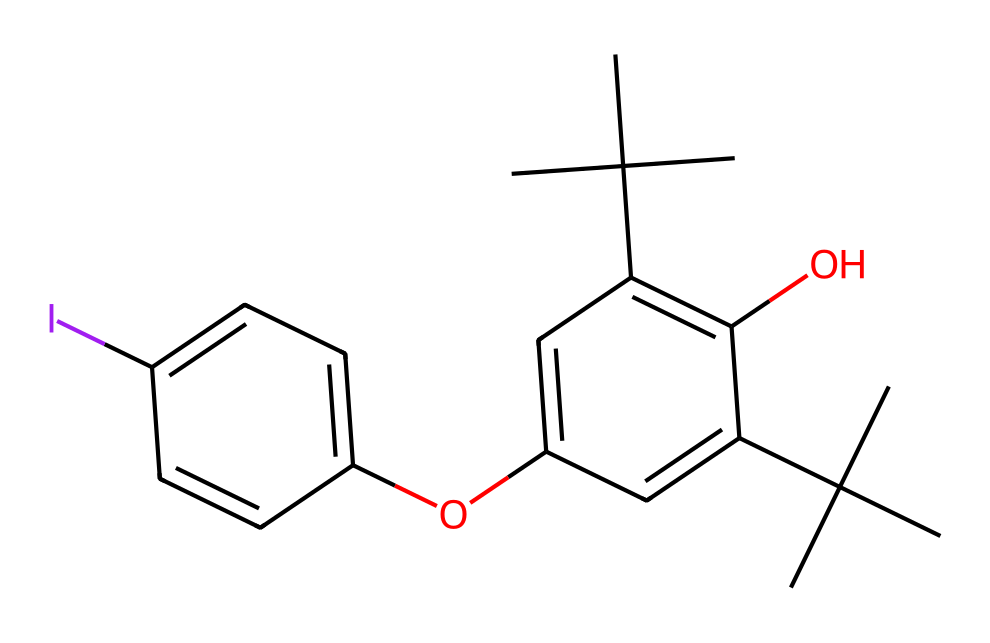what is the molecular formula of this compound? To determine the molecular formula, we count the different atoms present in the SMILES. The significant atomic symbols in the structure include carbon (C), hydrogen (H), iodine (I), and oxygen (O). By counting, we find C: 16, H: 18, O: 2, I: 1. Thus, the molecular formula is C16H18O2I.
Answer: C16H18O2I how many rings are present in the chemical structure? The structure features two benzene rings connected by ether linkages. Each benzene ring represents one cyclic structure. Therefore, when we count these, we find there are 2 rings present.
Answer: 2 what functional groups are present in this compound? Analyzing the structure, it can be observed that there are hydroxyl groups (–OH) attached to the benzene rings and an iodine atom indicating the presence of iodine functional group. Thus, the functional groups are hydroxyl and iodine.
Answer: hydroxyl, iodine is this compound considered hypervalent? Hypervalency is defined by the presence of an atom that has more than eight electrons in its valence shell. In this chemical, iodine is known to exhibit hypervalency. Given this, we conclude that the compound is indeed hypervalent due to the inclusion of iodine attached to the benzene structure, allowing it to accommodate more than 8 electrons.
Answer: yes which part of the structure contributes to its wood preservative properties? The iodine functional group is well-known for its antibacterial and antifungal properties, making it effective as a wood preservative. Therefore, looking at the structure, the iodine component primarily contributes to its preservative efficacy.
Answer: iodine how many hydroxyl groups are present? By examining the structure closely, we identify the presence of two hydroxyl groups (–OH) attached to the aromatic rings. Each hydroxyl group counts as one, leading us to a total of 2 hydroxyl groups present in the compound.
Answer: 2 